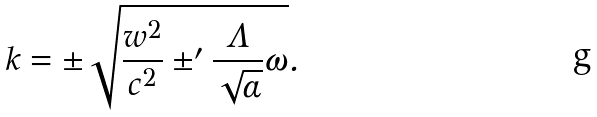<formula> <loc_0><loc_0><loc_500><loc_500>k = \pm \sqrt { \frac { w ^ { 2 } } { c ^ { 2 } } \pm ^ { \prime } \frac { \Lambda } { \sqrt { \alpha } } \omega } .</formula> 